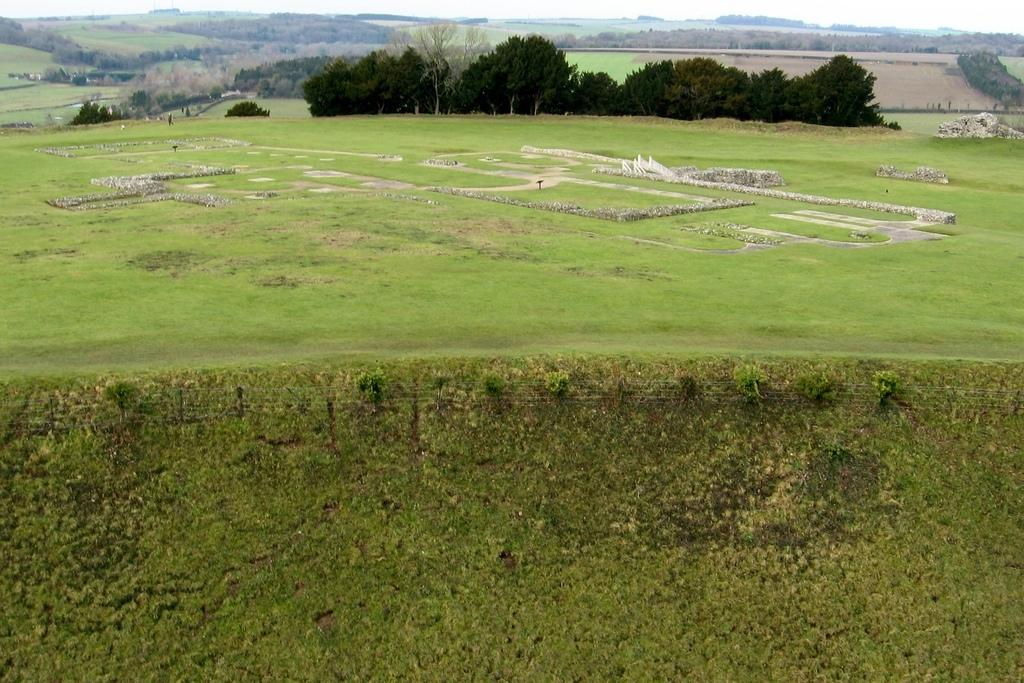What type of terrain is depicted in the image? The image consists of land. What can be seen at the bottom of the image? There is green grass at the bottom of the image. What is visible in the background of the image? There are trees in the background of the image. What objects are located in the middle of the image? There are rocks in the middle of the image. How many rings are being thrown in the image? There are no rings present in the image; it features land, grass, trees, and rocks. 